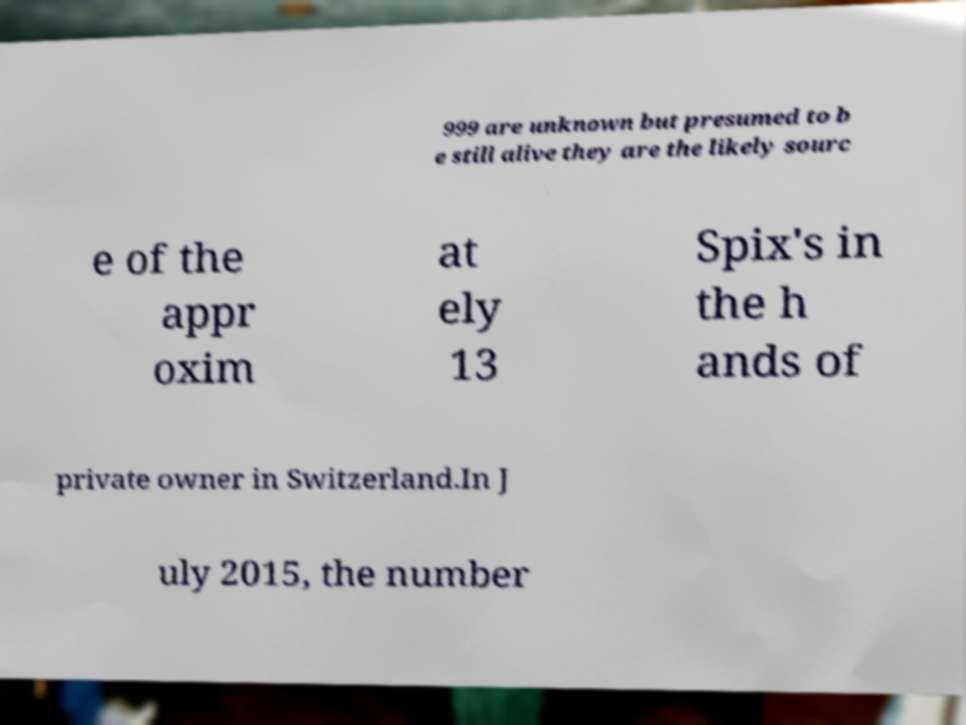Could you assist in decoding the text presented in this image and type it out clearly? 999 are unknown but presumed to b e still alive they are the likely sourc e of the appr oxim at ely 13 Spix's in the h ands of private owner in Switzerland.In J uly 2015, the number 